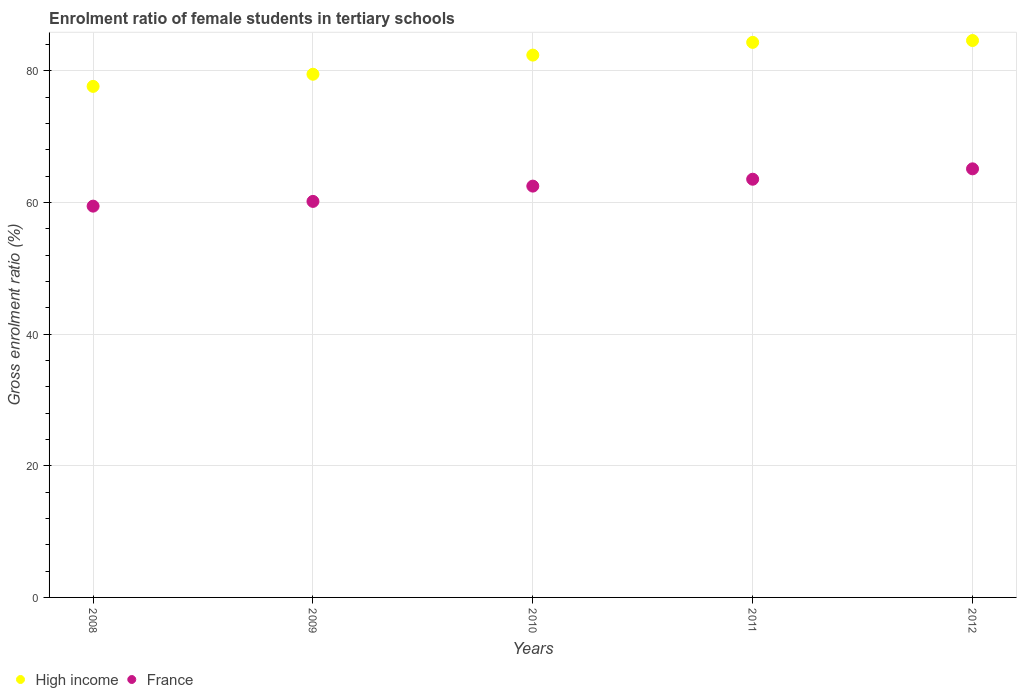Is the number of dotlines equal to the number of legend labels?
Offer a terse response. Yes. What is the enrolment ratio of female students in tertiary schools in France in 2010?
Keep it short and to the point. 62.48. Across all years, what is the maximum enrolment ratio of female students in tertiary schools in France?
Provide a short and direct response. 65.11. Across all years, what is the minimum enrolment ratio of female students in tertiary schools in High income?
Offer a terse response. 77.63. In which year was the enrolment ratio of female students in tertiary schools in High income minimum?
Give a very brief answer. 2008. What is the total enrolment ratio of female students in tertiary schools in High income in the graph?
Your answer should be very brief. 408.42. What is the difference between the enrolment ratio of female students in tertiary schools in High income in 2008 and that in 2011?
Your answer should be very brief. -6.68. What is the difference between the enrolment ratio of female students in tertiary schools in France in 2011 and the enrolment ratio of female students in tertiary schools in High income in 2010?
Offer a very short reply. -18.86. What is the average enrolment ratio of female students in tertiary schools in High income per year?
Offer a very short reply. 81.68. In the year 2012, what is the difference between the enrolment ratio of female students in tertiary schools in France and enrolment ratio of female students in tertiary schools in High income?
Offer a terse response. -19.49. In how many years, is the enrolment ratio of female students in tertiary schools in High income greater than 20 %?
Your response must be concise. 5. What is the ratio of the enrolment ratio of female students in tertiary schools in High income in 2009 to that in 2010?
Offer a very short reply. 0.96. Is the enrolment ratio of female students in tertiary schools in High income in 2008 less than that in 2011?
Provide a short and direct response. Yes. Is the difference between the enrolment ratio of female students in tertiary schools in France in 2008 and 2009 greater than the difference between the enrolment ratio of female students in tertiary schools in High income in 2008 and 2009?
Provide a short and direct response. Yes. What is the difference between the highest and the second highest enrolment ratio of female students in tertiary schools in High income?
Your answer should be very brief. 0.28. What is the difference between the highest and the lowest enrolment ratio of female students in tertiary schools in High income?
Provide a short and direct response. 6.97. In how many years, is the enrolment ratio of female students in tertiary schools in France greater than the average enrolment ratio of female students in tertiary schools in France taken over all years?
Ensure brevity in your answer.  3. Is the enrolment ratio of female students in tertiary schools in France strictly greater than the enrolment ratio of female students in tertiary schools in High income over the years?
Your response must be concise. No. Is the enrolment ratio of female students in tertiary schools in France strictly less than the enrolment ratio of female students in tertiary schools in High income over the years?
Your answer should be compact. Yes. Does the graph contain any zero values?
Your response must be concise. No. Where does the legend appear in the graph?
Give a very brief answer. Bottom left. How are the legend labels stacked?
Provide a short and direct response. Horizontal. What is the title of the graph?
Make the answer very short. Enrolment ratio of female students in tertiary schools. What is the label or title of the Y-axis?
Your response must be concise. Gross enrolment ratio (%). What is the Gross enrolment ratio (%) of High income in 2008?
Your answer should be compact. 77.63. What is the Gross enrolment ratio (%) in France in 2008?
Ensure brevity in your answer.  59.44. What is the Gross enrolment ratio (%) in High income in 2009?
Offer a very short reply. 79.48. What is the Gross enrolment ratio (%) in France in 2009?
Offer a very short reply. 60.16. What is the Gross enrolment ratio (%) in High income in 2010?
Provide a short and direct response. 82.39. What is the Gross enrolment ratio (%) of France in 2010?
Your answer should be very brief. 62.48. What is the Gross enrolment ratio (%) of High income in 2011?
Make the answer very short. 84.32. What is the Gross enrolment ratio (%) in France in 2011?
Give a very brief answer. 63.53. What is the Gross enrolment ratio (%) in High income in 2012?
Offer a terse response. 84.6. What is the Gross enrolment ratio (%) of France in 2012?
Provide a short and direct response. 65.11. Across all years, what is the maximum Gross enrolment ratio (%) in High income?
Provide a short and direct response. 84.6. Across all years, what is the maximum Gross enrolment ratio (%) in France?
Keep it short and to the point. 65.11. Across all years, what is the minimum Gross enrolment ratio (%) of High income?
Provide a short and direct response. 77.63. Across all years, what is the minimum Gross enrolment ratio (%) of France?
Your answer should be compact. 59.44. What is the total Gross enrolment ratio (%) of High income in the graph?
Offer a terse response. 408.42. What is the total Gross enrolment ratio (%) in France in the graph?
Make the answer very short. 310.73. What is the difference between the Gross enrolment ratio (%) in High income in 2008 and that in 2009?
Provide a short and direct response. -1.84. What is the difference between the Gross enrolment ratio (%) in France in 2008 and that in 2009?
Your answer should be very brief. -0.72. What is the difference between the Gross enrolment ratio (%) in High income in 2008 and that in 2010?
Give a very brief answer. -4.75. What is the difference between the Gross enrolment ratio (%) of France in 2008 and that in 2010?
Your answer should be very brief. -3.04. What is the difference between the Gross enrolment ratio (%) in High income in 2008 and that in 2011?
Make the answer very short. -6.68. What is the difference between the Gross enrolment ratio (%) in France in 2008 and that in 2011?
Your answer should be compact. -4.09. What is the difference between the Gross enrolment ratio (%) of High income in 2008 and that in 2012?
Provide a succinct answer. -6.97. What is the difference between the Gross enrolment ratio (%) of France in 2008 and that in 2012?
Keep it short and to the point. -5.67. What is the difference between the Gross enrolment ratio (%) in High income in 2009 and that in 2010?
Your answer should be very brief. -2.91. What is the difference between the Gross enrolment ratio (%) of France in 2009 and that in 2010?
Provide a succinct answer. -2.32. What is the difference between the Gross enrolment ratio (%) in High income in 2009 and that in 2011?
Keep it short and to the point. -4.84. What is the difference between the Gross enrolment ratio (%) in France in 2009 and that in 2011?
Keep it short and to the point. -3.37. What is the difference between the Gross enrolment ratio (%) of High income in 2009 and that in 2012?
Provide a short and direct response. -5.12. What is the difference between the Gross enrolment ratio (%) in France in 2009 and that in 2012?
Provide a short and direct response. -4.95. What is the difference between the Gross enrolment ratio (%) in High income in 2010 and that in 2011?
Your response must be concise. -1.93. What is the difference between the Gross enrolment ratio (%) of France in 2010 and that in 2011?
Your answer should be compact. -1.05. What is the difference between the Gross enrolment ratio (%) of High income in 2010 and that in 2012?
Your answer should be very brief. -2.21. What is the difference between the Gross enrolment ratio (%) of France in 2010 and that in 2012?
Make the answer very short. -2.62. What is the difference between the Gross enrolment ratio (%) in High income in 2011 and that in 2012?
Your answer should be very brief. -0.28. What is the difference between the Gross enrolment ratio (%) in France in 2011 and that in 2012?
Give a very brief answer. -1.58. What is the difference between the Gross enrolment ratio (%) of High income in 2008 and the Gross enrolment ratio (%) of France in 2009?
Provide a short and direct response. 17.47. What is the difference between the Gross enrolment ratio (%) in High income in 2008 and the Gross enrolment ratio (%) in France in 2010?
Your response must be concise. 15.15. What is the difference between the Gross enrolment ratio (%) in High income in 2008 and the Gross enrolment ratio (%) in France in 2011?
Provide a succinct answer. 14.1. What is the difference between the Gross enrolment ratio (%) in High income in 2008 and the Gross enrolment ratio (%) in France in 2012?
Your answer should be compact. 12.53. What is the difference between the Gross enrolment ratio (%) of High income in 2009 and the Gross enrolment ratio (%) of France in 2010?
Your response must be concise. 16.99. What is the difference between the Gross enrolment ratio (%) of High income in 2009 and the Gross enrolment ratio (%) of France in 2011?
Make the answer very short. 15.95. What is the difference between the Gross enrolment ratio (%) of High income in 2009 and the Gross enrolment ratio (%) of France in 2012?
Provide a short and direct response. 14.37. What is the difference between the Gross enrolment ratio (%) of High income in 2010 and the Gross enrolment ratio (%) of France in 2011?
Make the answer very short. 18.86. What is the difference between the Gross enrolment ratio (%) in High income in 2010 and the Gross enrolment ratio (%) in France in 2012?
Your answer should be compact. 17.28. What is the difference between the Gross enrolment ratio (%) of High income in 2011 and the Gross enrolment ratio (%) of France in 2012?
Provide a short and direct response. 19.21. What is the average Gross enrolment ratio (%) of High income per year?
Provide a short and direct response. 81.68. What is the average Gross enrolment ratio (%) of France per year?
Your response must be concise. 62.15. In the year 2008, what is the difference between the Gross enrolment ratio (%) of High income and Gross enrolment ratio (%) of France?
Your answer should be very brief. 18.19. In the year 2009, what is the difference between the Gross enrolment ratio (%) in High income and Gross enrolment ratio (%) in France?
Ensure brevity in your answer.  19.32. In the year 2010, what is the difference between the Gross enrolment ratio (%) in High income and Gross enrolment ratio (%) in France?
Offer a terse response. 19.9. In the year 2011, what is the difference between the Gross enrolment ratio (%) in High income and Gross enrolment ratio (%) in France?
Keep it short and to the point. 20.79. In the year 2012, what is the difference between the Gross enrolment ratio (%) in High income and Gross enrolment ratio (%) in France?
Offer a terse response. 19.49. What is the ratio of the Gross enrolment ratio (%) in High income in 2008 to that in 2009?
Give a very brief answer. 0.98. What is the ratio of the Gross enrolment ratio (%) of High income in 2008 to that in 2010?
Ensure brevity in your answer.  0.94. What is the ratio of the Gross enrolment ratio (%) in France in 2008 to that in 2010?
Your answer should be very brief. 0.95. What is the ratio of the Gross enrolment ratio (%) in High income in 2008 to that in 2011?
Ensure brevity in your answer.  0.92. What is the ratio of the Gross enrolment ratio (%) of France in 2008 to that in 2011?
Ensure brevity in your answer.  0.94. What is the ratio of the Gross enrolment ratio (%) of High income in 2008 to that in 2012?
Provide a short and direct response. 0.92. What is the ratio of the Gross enrolment ratio (%) of France in 2008 to that in 2012?
Your response must be concise. 0.91. What is the ratio of the Gross enrolment ratio (%) of High income in 2009 to that in 2010?
Provide a succinct answer. 0.96. What is the ratio of the Gross enrolment ratio (%) in France in 2009 to that in 2010?
Provide a short and direct response. 0.96. What is the ratio of the Gross enrolment ratio (%) of High income in 2009 to that in 2011?
Your answer should be very brief. 0.94. What is the ratio of the Gross enrolment ratio (%) in France in 2009 to that in 2011?
Give a very brief answer. 0.95. What is the ratio of the Gross enrolment ratio (%) of High income in 2009 to that in 2012?
Keep it short and to the point. 0.94. What is the ratio of the Gross enrolment ratio (%) of France in 2009 to that in 2012?
Your answer should be compact. 0.92. What is the ratio of the Gross enrolment ratio (%) in High income in 2010 to that in 2011?
Offer a terse response. 0.98. What is the ratio of the Gross enrolment ratio (%) of France in 2010 to that in 2011?
Provide a succinct answer. 0.98. What is the ratio of the Gross enrolment ratio (%) in High income in 2010 to that in 2012?
Ensure brevity in your answer.  0.97. What is the ratio of the Gross enrolment ratio (%) in France in 2010 to that in 2012?
Provide a short and direct response. 0.96. What is the ratio of the Gross enrolment ratio (%) of High income in 2011 to that in 2012?
Make the answer very short. 1. What is the ratio of the Gross enrolment ratio (%) of France in 2011 to that in 2012?
Ensure brevity in your answer.  0.98. What is the difference between the highest and the second highest Gross enrolment ratio (%) of High income?
Your answer should be very brief. 0.28. What is the difference between the highest and the second highest Gross enrolment ratio (%) in France?
Your answer should be compact. 1.58. What is the difference between the highest and the lowest Gross enrolment ratio (%) of High income?
Provide a short and direct response. 6.97. What is the difference between the highest and the lowest Gross enrolment ratio (%) in France?
Give a very brief answer. 5.67. 